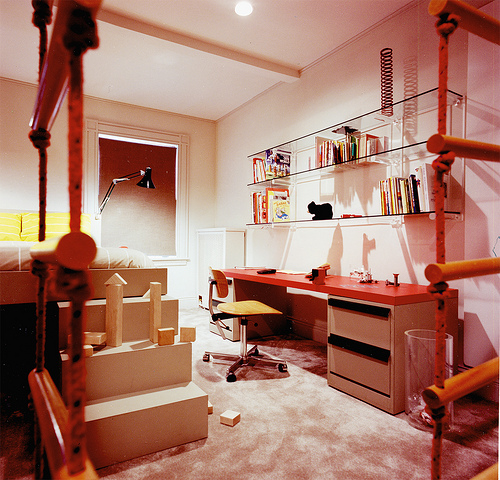<image>What room is pictured? It is ambiguous what room is pictured. It could be a bedroom or an office. What room is pictured? The room pictured is most likely a bedroom. 